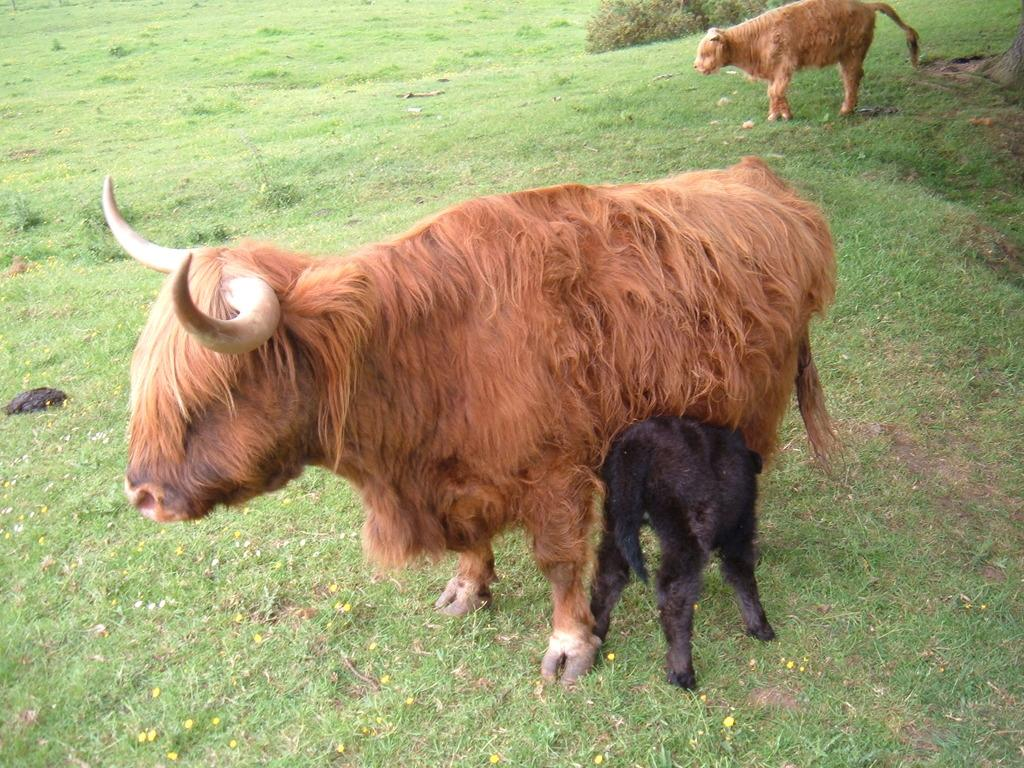What type of animals are in the image? There are sheep in the image. Where are the sheep located? The sheep are in the grass. What type of powder is being used by the coach in the mine in the image? There is no coach or mine present in the image; it features sheep in the grass. 